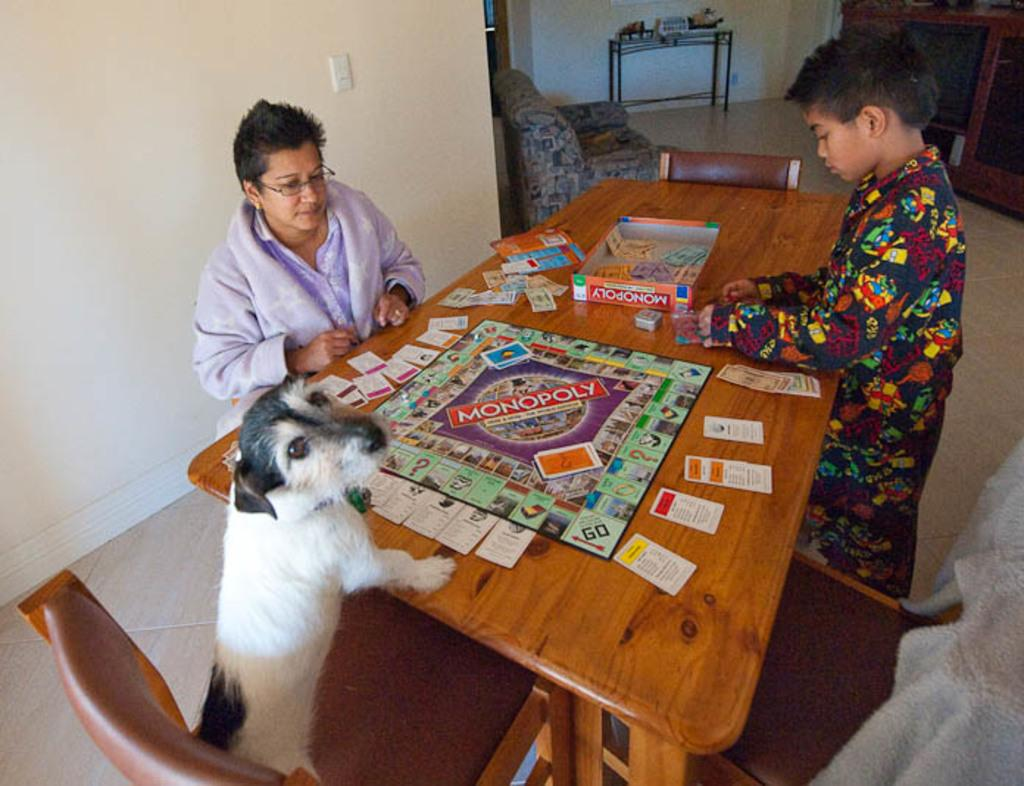What is the woman doing in the image? The woman is sitting at a table. What is on the table with the woman? There is a board game with cards on the table. Who else is present in the image? A boy is standing beside the table. What is the dog doing in the image? The dog is standing in a chair. Where is the hen taking a bath in the image? There is no hen or bath present in the image. 